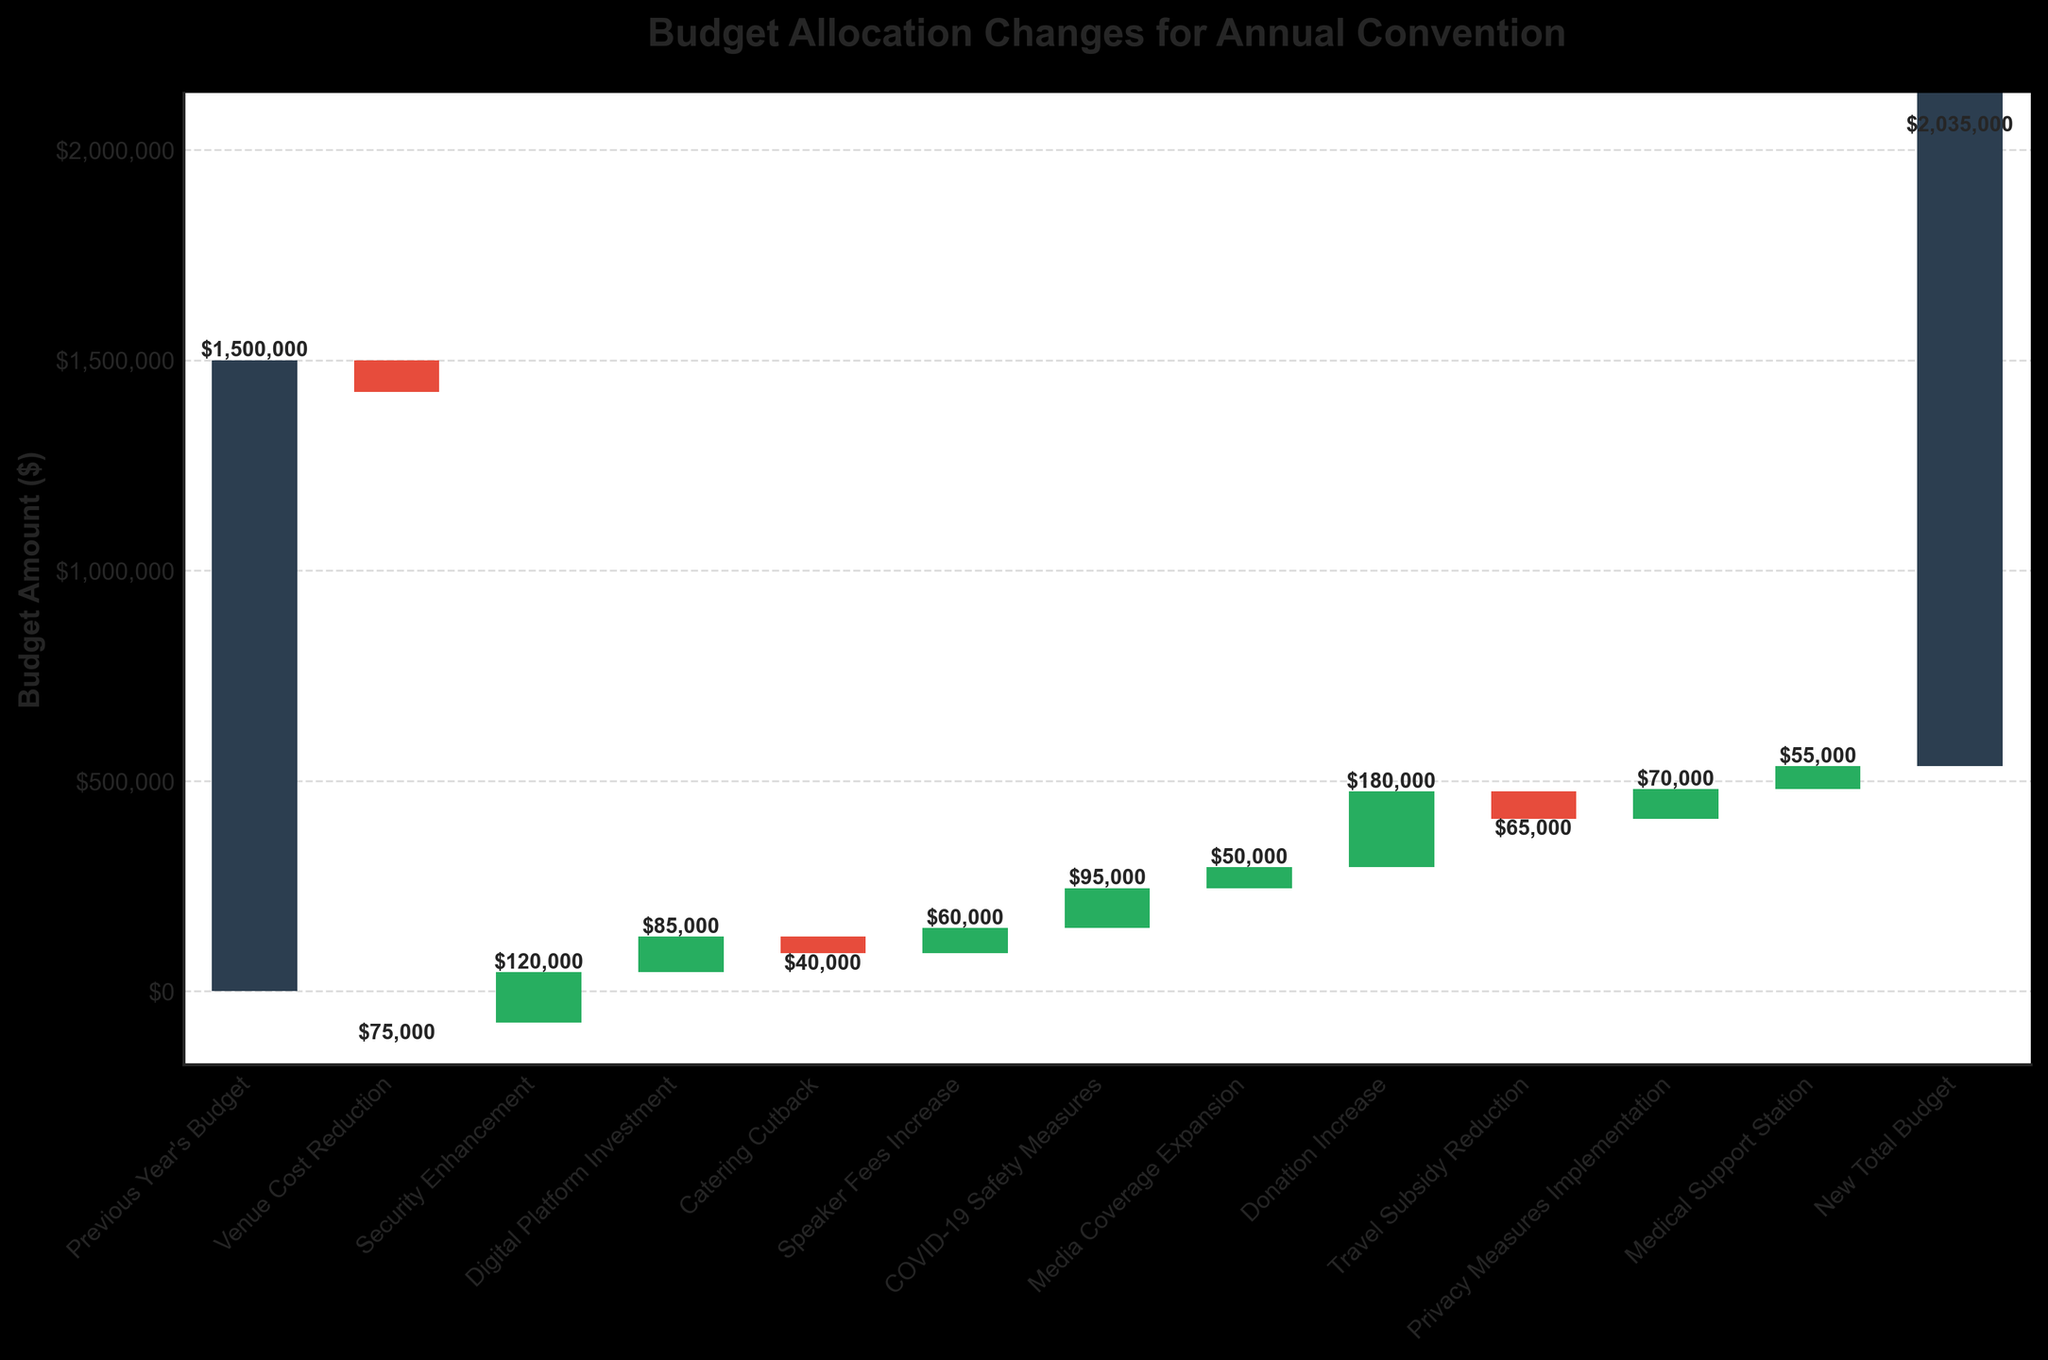What is the title of the chart? The title is found at the top of the chart and it provides a summary of the figure's content. The title reads "Budget Allocation Changes for Annual Convention".
Answer: Budget Allocation Changes for Annual Convention How much was allocated for COVID-19 Safety Measures? Look for the bar labeled "COVID-19 Safety Measures" and check its value. The bar's value is $95,000.
Answer: $95,000 What was the previous year's budget for the annual convention? Locate the initial bar in the chart, which represents the previous year's budget. The label and value for this bar are $1,500,000.
Answer: $1,500,000 How much did the budget increase due to the Donation Increase? Locate the bar labeled "Donation Increase" and check the value next to it. It shows an increase of $180,000.
Answer: $180,000 What is the net change in the budget from the Venue Cost Reduction, Catering Cutback, and Travel Subsidy Reduction combined? Identify the values of the bars for "Venue Cost Reduction" (-$75,000), "Catering Cutback" (-$40,000), and "Travel Subsidy Reduction" (-$65,000). Sum these values: -$75,000 - $40,000 - $65,000 = -$180,000.
Answer: -$180,000 What is the new total budget for the annual convention? The new total budget is represented by the final bar labeled "New Total Budget". Its value is $2,035,000.
Answer: $2,035,000 Which category had the highest increase, and how much was it? Compare the positive values of the bars. The "Donation Increase" had the highest value at $180,000.
Answer: Donation Increase, $180,000 How much was the budget increased for Media Coverage Expansion? Locate the bar labeled "Media Coverage Expansion" and identify its value. The increase is $50,000.
Answer: $50,000 What was the financial effect of implementing Privacy Measures on the budget? Look at the value associated with the "Privacy Measures Implementation" bar. The budget increased by $70,000 due to implementing privacy measures.
Answer: $70,000 Combining the increments from Security Enhancement and Digital Platform Investment, what is the total increase in the budget from these two categories? Find the values for "Security Enhancement" ($120,000) and "Digital Platform Investment" ($85,000). Add these values together: $120,000 + $85,000 = $205,000.
Answer: $205,000 